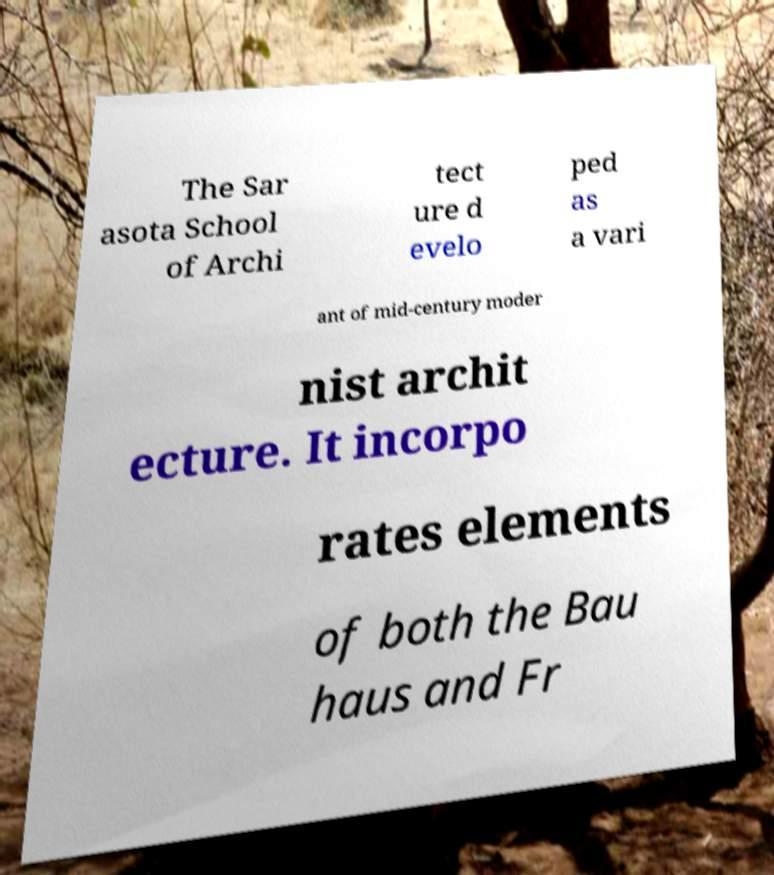Can you accurately transcribe the text from the provided image for me? The Sar asota School of Archi tect ure d evelo ped as a vari ant of mid-century moder nist archit ecture. It incorpo rates elements of both the Bau haus and Fr 